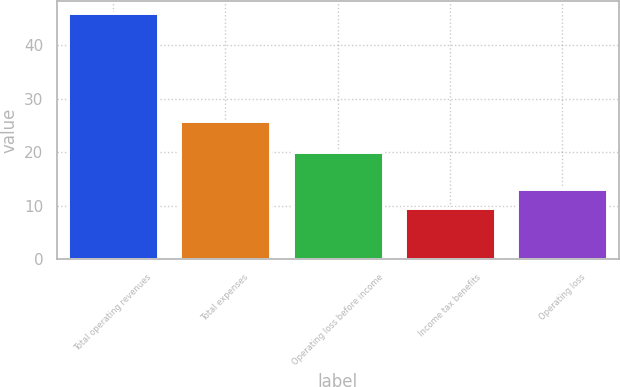Convert chart to OTSL. <chart><loc_0><loc_0><loc_500><loc_500><bar_chart><fcel>Total operating revenues<fcel>Total expenses<fcel>Operating loss before income<fcel>Income tax benefits<fcel>Operating loss<nl><fcel>45.9<fcel>25.9<fcel>20<fcel>9.6<fcel>13.23<nl></chart> 